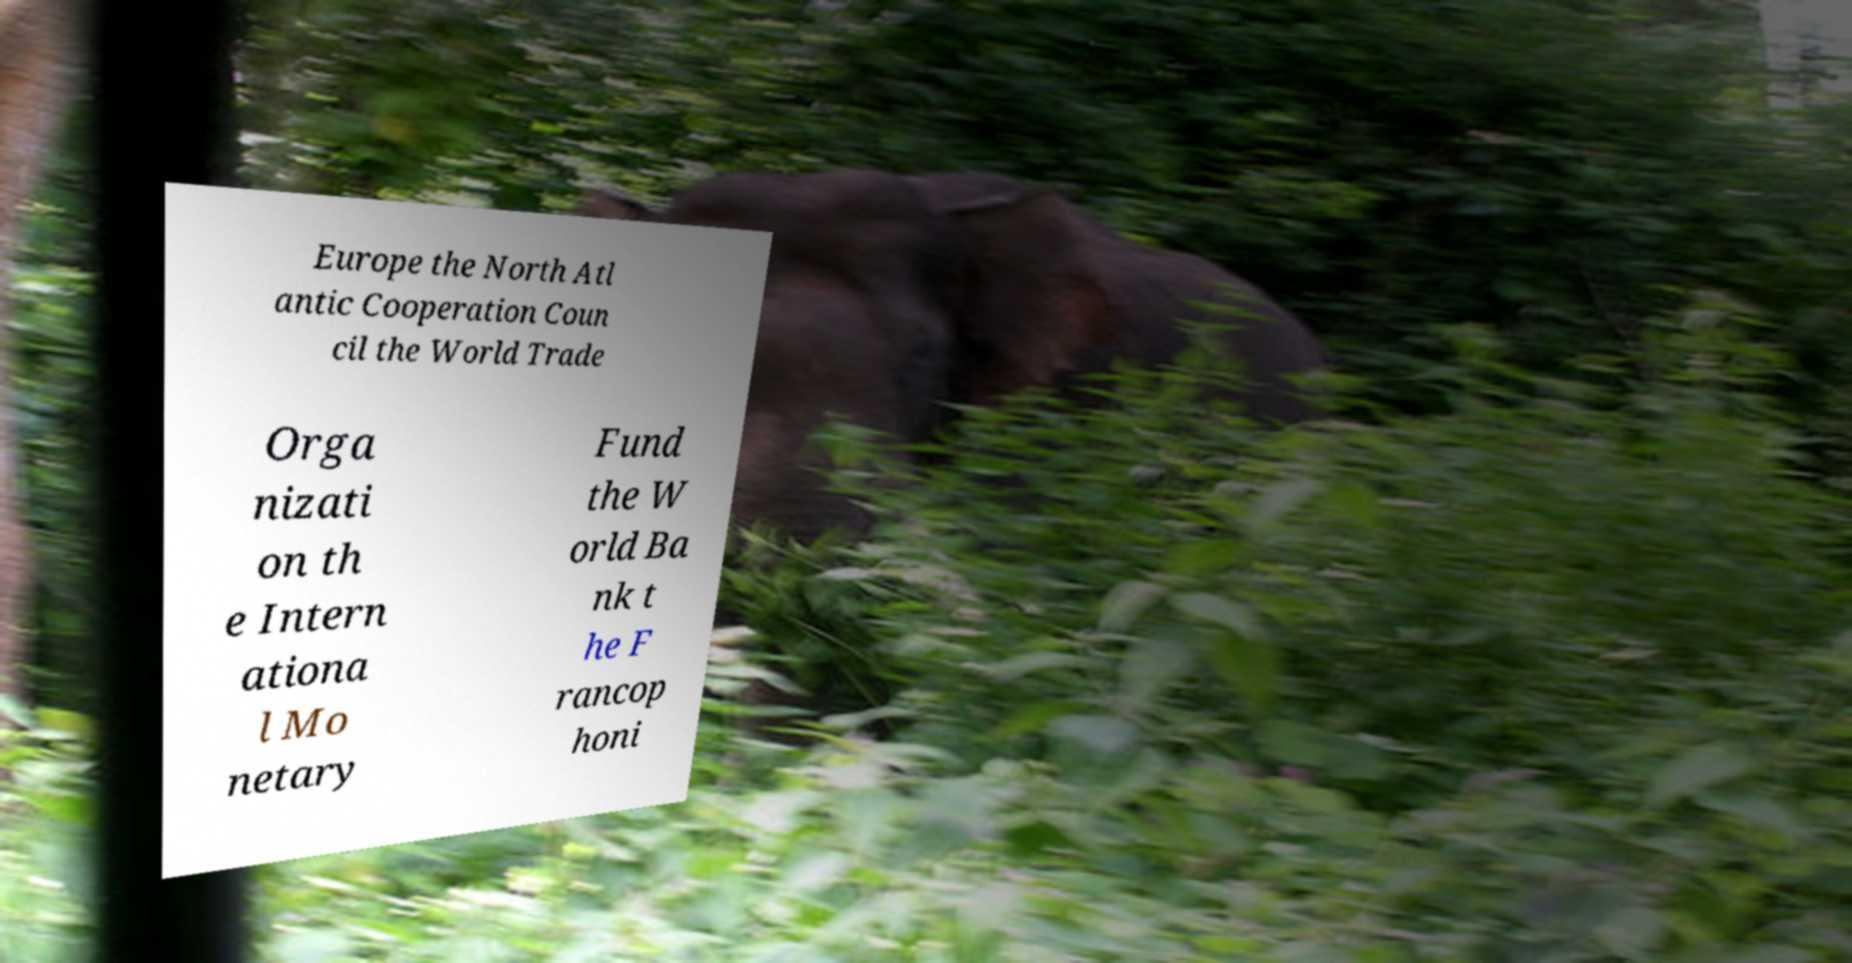There's text embedded in this image that I need extracted. Can you transcribe it verbatim? Europe the North Atl antic Cooperation Coun cil the World Trade Orga nizati on th e Intern ationa l Mo netary Fund the W orld Ba nk t he F rancop honi 